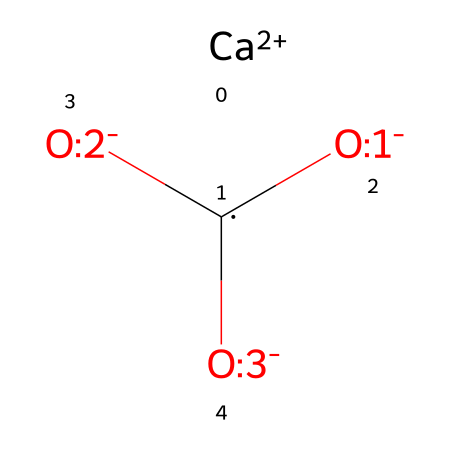What is the total number of oxygen atoms in this compound? Looking at the SMILES representation, we can identify three distinct oxygen atoms represented by the brackets [O-:1], [O-:2], and [O-:3]. Counting these gives a total of three oxygen atoms.
Answer: three What is the charge of the calcium ion in this structure? The calcium ion is represented in the SMILES as [Ca+2], indicating that it has a charge of +2.
Answer: +2 How many total atoms are present in this molecule? The chemical structure contains one calcium atom, one carbon atom, and three oxygen atoms. Adding these gives a total of five atoms.
Answer: five What type of chemical bonding is primarily present in this compound? The interactions between the calcium ion and the carbonate group involve ionic bonding, as they are oppositely charged species. Therefore, the primary type of chemical bonding in this compound is ionic.
Answer: ionic What is the central atom in the carbonate part of the molecule? In the carbonate group, which is represented by the format [C+0]([O-:1])([O-:2])[O-:3], the central atom is carbon, as it is shown at the center of the functional group.
Answer: carbon How does the presence of the calcium ion influence the stability of calcium carbonate? The calcium ion (Ca+2) contributes to the stability of calcium carbonate through electrostatic interactions with the negatively charged carbonate ions (CO3), resulting in a stable ionic compound.
Answer: stability What kind of compound is calcium carbonate classified as? Calcium carbonate is classified as a coordination compound due to the presence of the calcium ion coordinated with the carbonate group.
Answer: coordination compound 